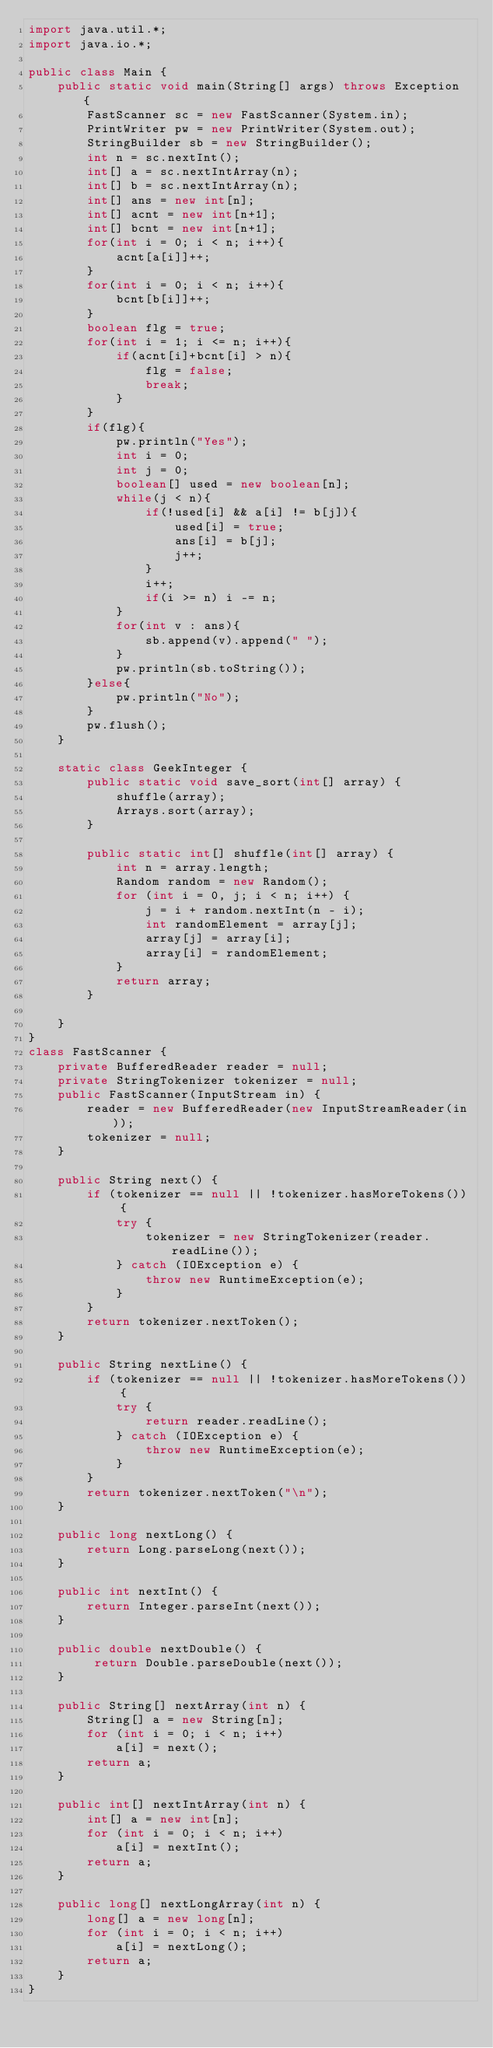<code> <loc_0><loc_0><loc_500><loc_500><_Java_>import java.util.*;
import java.io.*;
 
public class Main {
    public static void main(String[] args) throws Exception {
        FastScanner sc = new FastScanner(System.in);
        PrintWriter pw = new PrintWriter(System.out);
        StringBuilder sb = new StringBuilder();
        int n = sc.nextInt();
        int[] a = sc.nextIntArray(n);
        int[] b = sc.nextIntArray(n);
        int[] ans = new int[n];
        int[] acnt = new int[n+1];
        int[] bcnt = new int[n+1];
        for(int i = 0; i < n; i++){
            acnt[a[i]]++;
        }
        for(int i = 0; i < n; i++){
            bcnt[b[i]]++;
        }
        boolean flg = true;
        for(int i = 1; i <= n; i++){
            if(acnt[i]+bcnt[i] > n){
                flg = false;
                break;
            }
        }
        if(flg){
            pw.println("Yes");
            int i = 0;
            int j = 0;
            boolean[] used = new boolean[n];
            while(j < n){
                if(!used[i] && a[i] != b[j]){
                    used[i] = true;
                    ans[i] = b[j];
                    j++;
                }
                i++;
                if(i >= n) i -= n;
            }
            for(int v : ans){
                sb.append(v).append(" ");
            }
            pw.println(sb.toString());
        }else{
            pw.println("No");
        }
        pw.flush();
    }

    static class GeekInteger {
        public static void save_sort(int[] array) {
            shuffle(array);
            Arrays.sort(array);
        }
 
        public static int[] shuffle(int[] array) {
            int n = array.length;
            Random random = new Random();
            for (int i = 0, j; i < n; i++) {
                j = i + random.nextInt(n - i);
                int randomElement = array[j];
                array[j] = array[i];
                array[i] = randomElement;
            }
            return array;
        }
 
    }
}
class FastScanner {
    private BufferedReader reader = null;
    private StringTokenizer tokenizer = null;
    public FastScanner(InputStream in) {
        reader = new BufferedReader(new InputStreamReader(in));
        tokenizer = null;
    }

    public String next() {
        if (tokenizer == null || !tokenizer.hasMoreTokens()) {
            try {
                tokenizer = new StringTokenizer(reader.readLine());
            } catch (IOException e) {
                throw new RuntimeException(e);
            }
        }
        return tokenizer.nextToken();
    }

    public String nextLine() {
        if (tokenizer == null || !tokenizer.hasMoreTokens()) {
            try {
                return reader.readLine();
            } catch (IOException e) {
                throw new RuntimeException(e);
            }
        }
        return tokenizer.nextToken("\n");
    }

    public long nextLong() {
        return Long.parseLong(next());
    }

    public int nextInt() {
        return Integer.parseInt(next());
    }

    public double nextDouble() {
         return Double.parseDouble(next());
    }
    
    public String[] nextArray(int n) {
        String[] a = new String[n];
        for (int i = 0; i < n; i++)
            a[i] = next();
        return a;
    }

    public int[] nextIntArray(int n) {
        int[] a = new int[n];
        for (int i = 0; i < n; i++)
            a[i] = nextInt();
        return a;
    }

    public long[] nextLongArray(int n) {
        long[] a = new long[n];
        for (int i = 0; i < n; i++)
            a[i] = nextLong();
        return a;
    } 
}
</code> 